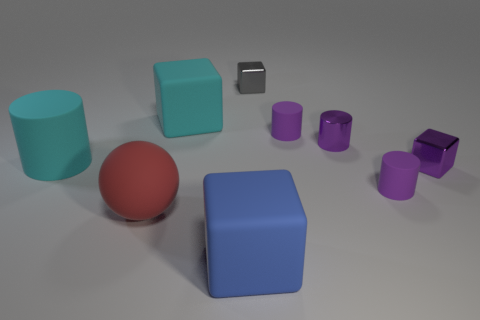Can you describe the arrangement of the shapes on the surface and their relative sizes? Certainly. The arrangement on the surface appears methodical, displaying a variety of geometric shapes that vary in size. A prominent large red sphere, large blue and a smaller purple cube are placed relatively at the center of this composition. To the right, a size progression of purple cylinders reduce in scale, showcasing a dramatic transition from larger to smaller forms. Lastly, a solitary black shape resembling a smartphone lies between the central blue and smaller purple cubes, adding a non-geometric contrasting element to the mix. 